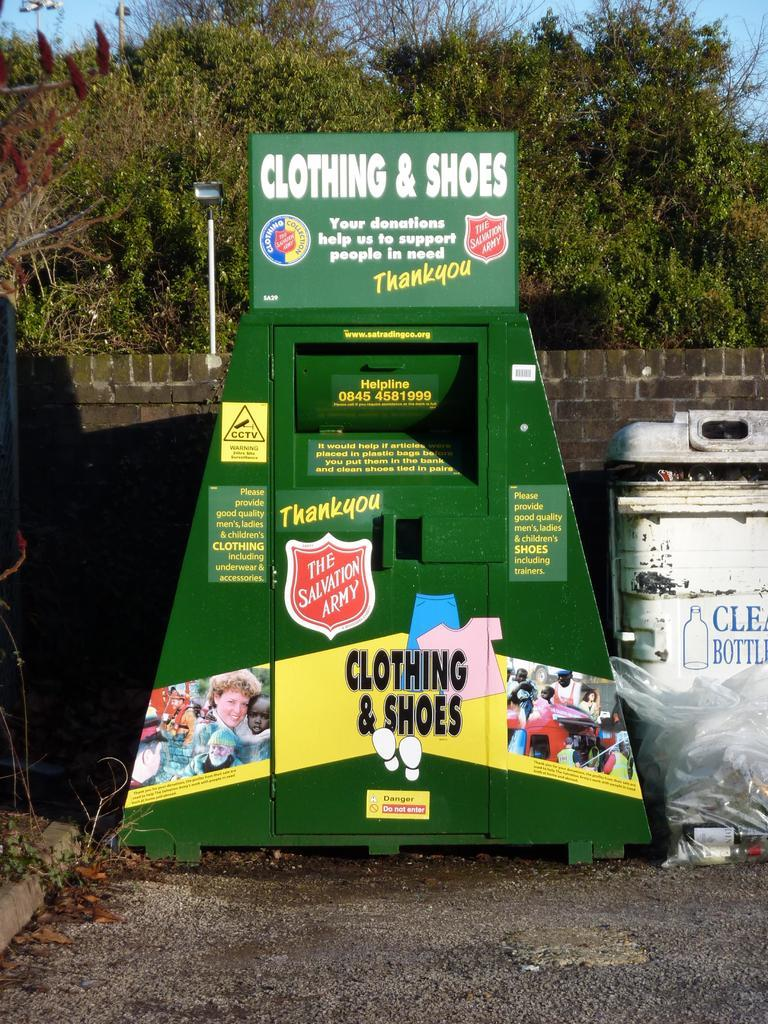<image>
Present a compact description of the photo's key features. Clothing and Shoes Donation Drop Off that is provided by the Salvation Army. 